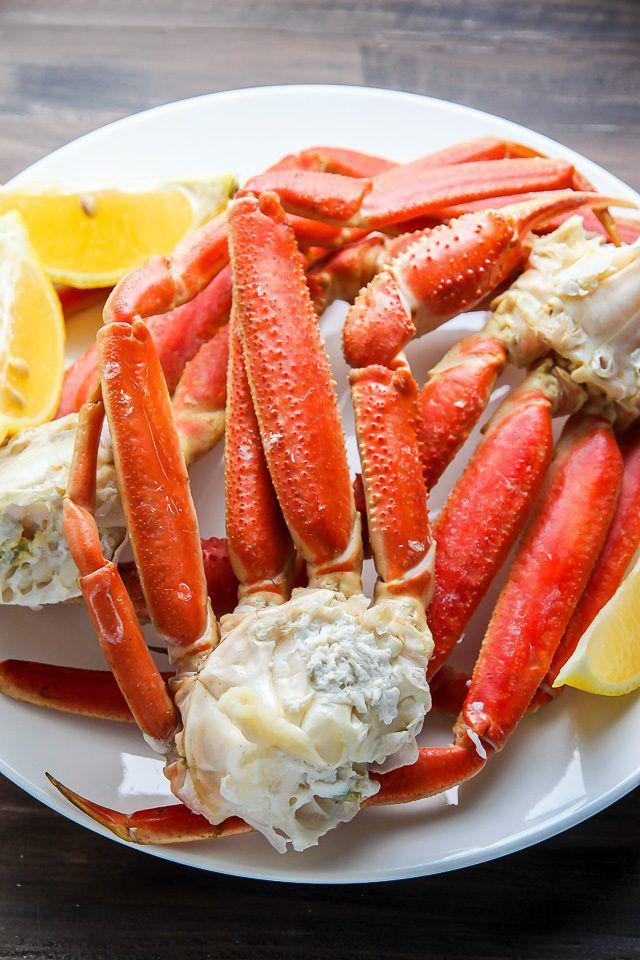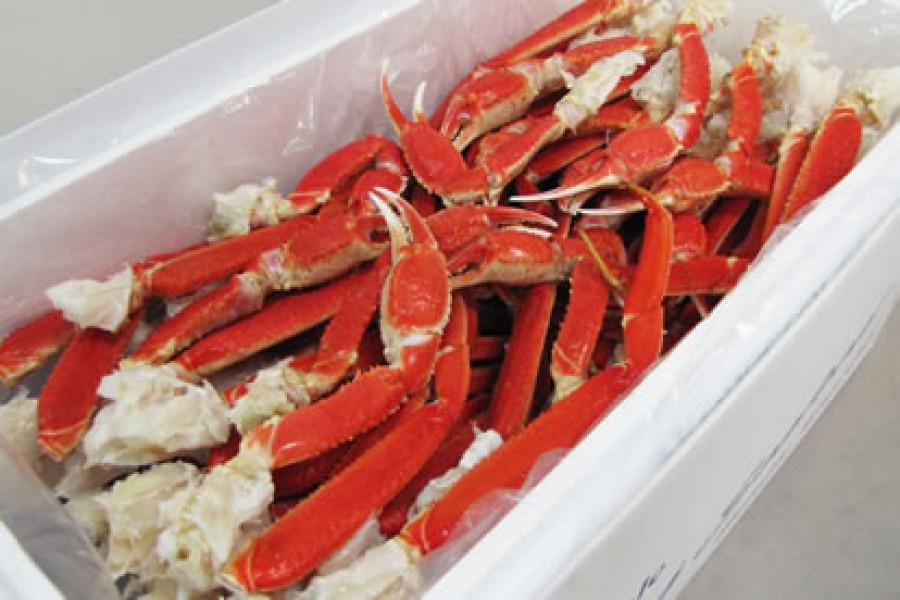The first image is the image on the left, the second image is the image on the right. For the images shown, is this caption "One image shows long red crab legs connected by whitish meat served on a round white plate." true? Answer yes or no. Yes. 